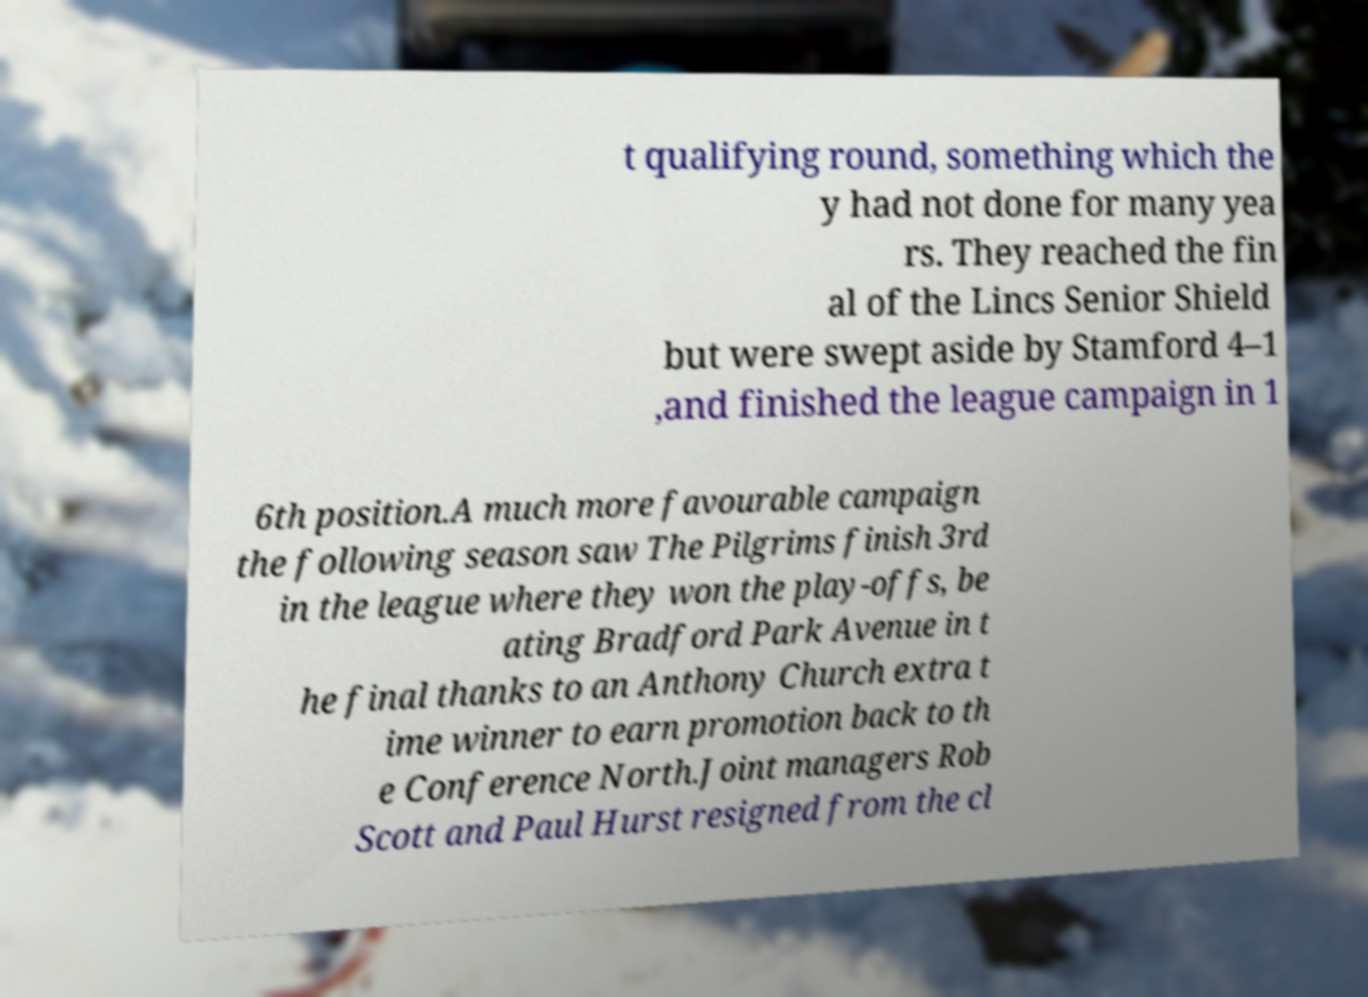For documentation purposes, I need the text within this image transcribed. Could you provide that? t qualifying round, something which the y had not done for many yea rs. They reached the fin al of the Lincs Senior Shield but were swept aside by Stamford 4–1 ,and finished the league campaign in 1 6th position.A much more favourable campaign the following season saw The Pilgrims finish 3rd in the league where they won the play-offs, be ating Bradford Park Avenue in t he final thanks to an Anthony Church extra t ime winner to earn promotion back to th e Conference North.Joint managers Rob Scott and Paul Hurst resigned from the cl 